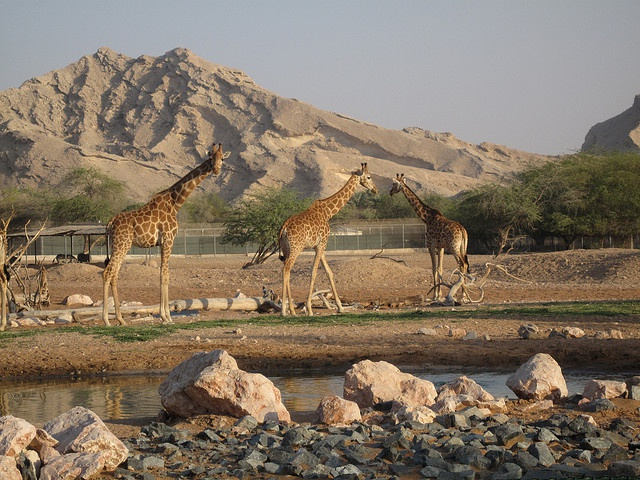Describe the objects in this image and their specific colors. I can see giraffe in darkgray, brown, tan, maroon, and gray tones, giraffe in darkgray, tan, brown, and gray tones, and giraffe in darkgray, black, maroon, and gray tones in this image. 